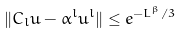Convert formula to latex. <formula><loc_0><loc_0><loc_500><loc_500>\| C _ { l } u - \alpha ^ { l } u ^ { l } \| \leq e ^ { - L ^ { \beta } / 3 }</formula> 